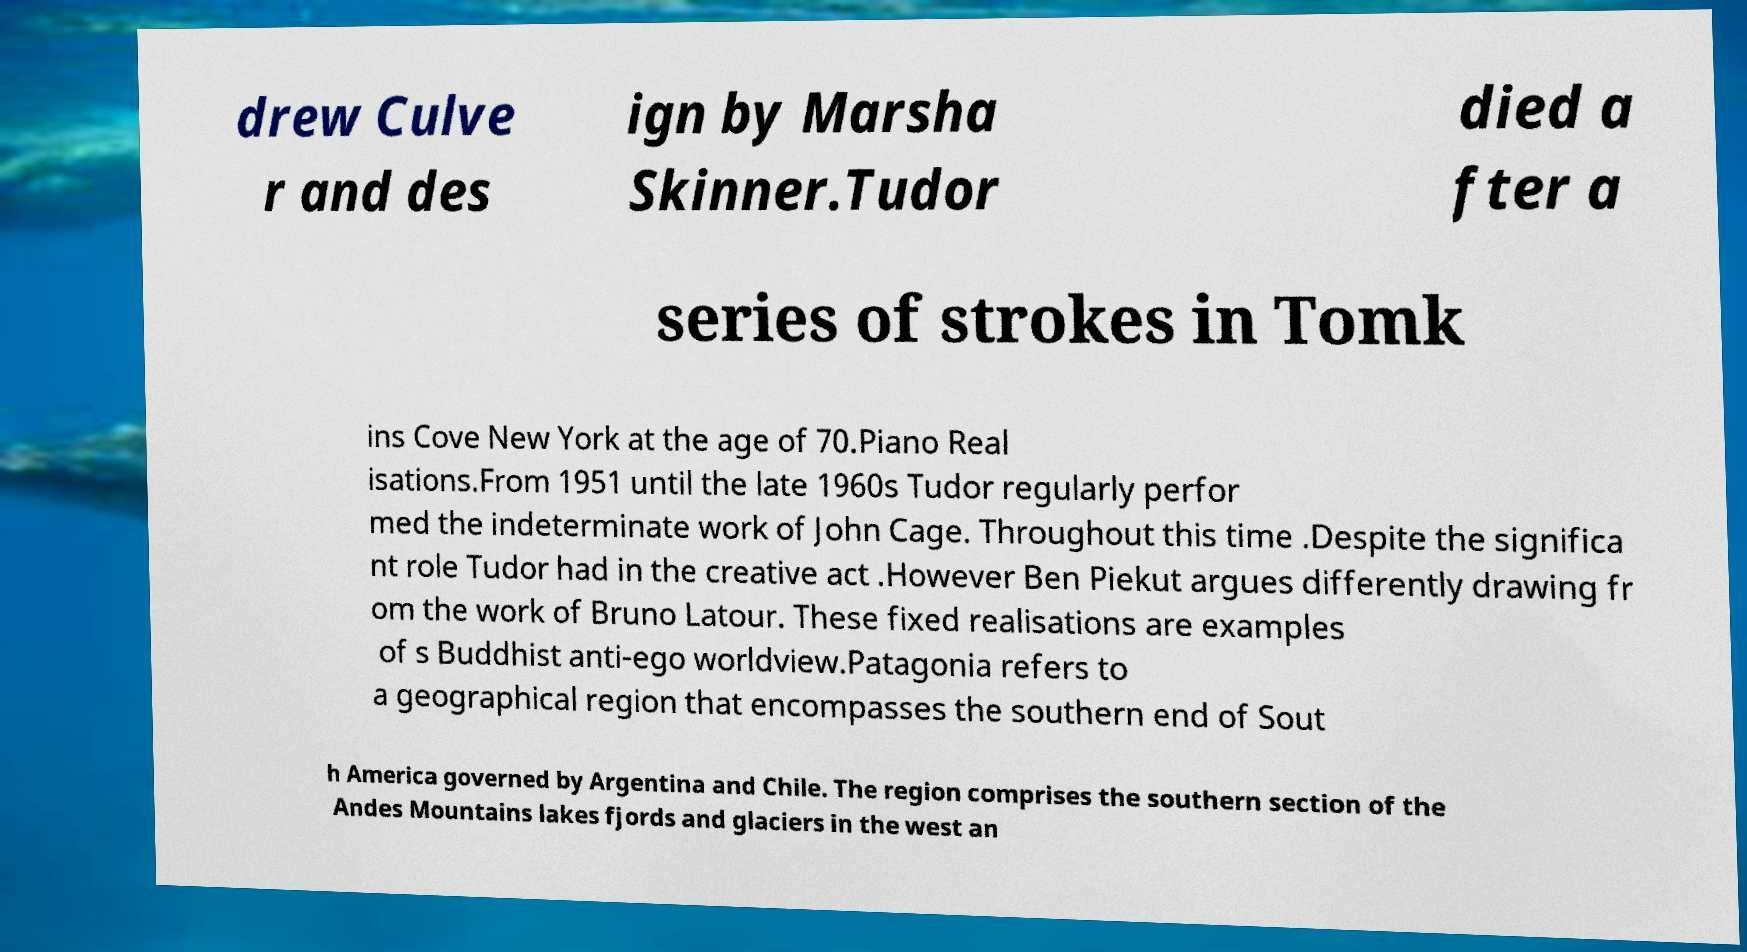I need the written content from this picture converted into text. Can you do that? drew Culve r and des ign by Marsha Skinner.Tudor died a fter a series of strokes in Tomk ins Cove New York at the age of 70.Piano Real isations.From 1951 until the late 1960s Tudor regularly perfor med the indeterminate work of John Cage. Throughout this time .Despite the significa nt role Tudor had in the creative act .However Ben Piekut argues differently drawing fr om the work of Bruno Latour. These fixed realisations are examples of s Buddhist anti-ego worldview.Patagonia refers to a geographical region that encompasses the southern end of Sout h America governed by Argentina and Chile. The region comprises the southern section of the Andes Mountains lakes fjords and glaciers in the west an 